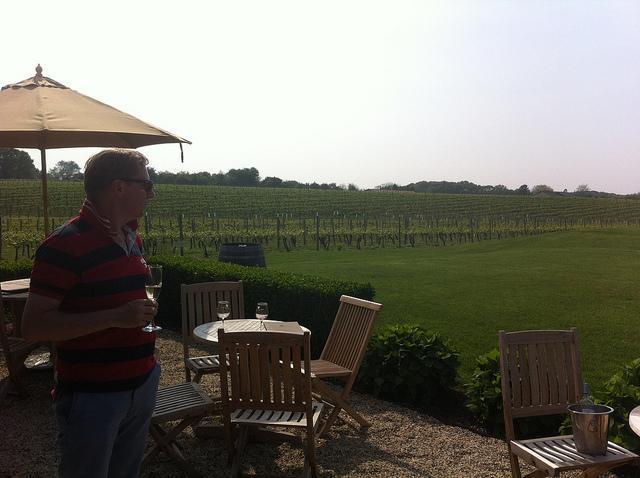How many chairs are visible?
Give a very brief answer. 5. How many chairs can you see?
Give a very brief answer. 6. How many kites are in this picture?
Give a very brief answer. 0. 